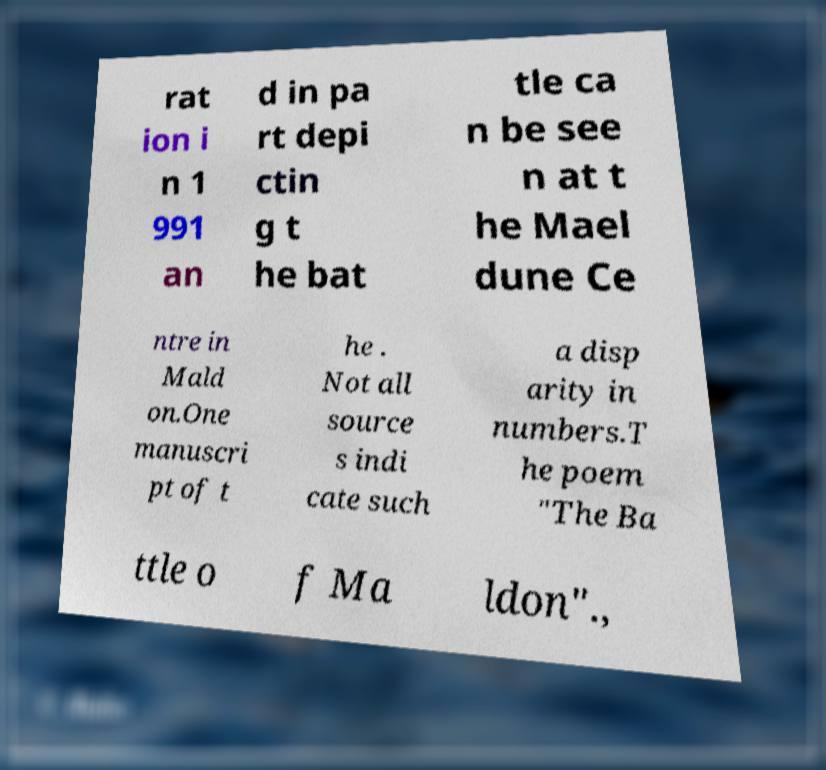Please identify and transcribe the text found in this image. rat ion i n 1 991 an d in pa rt depi ctin g t he bat tle ca n be see n at t he Mael dune Ce ntre in Mald on.One manuscri pt of t he . Not all source s indi cate such a disp arity in numbers.T he poem "The Ba ttle o f Ma ldon"., 